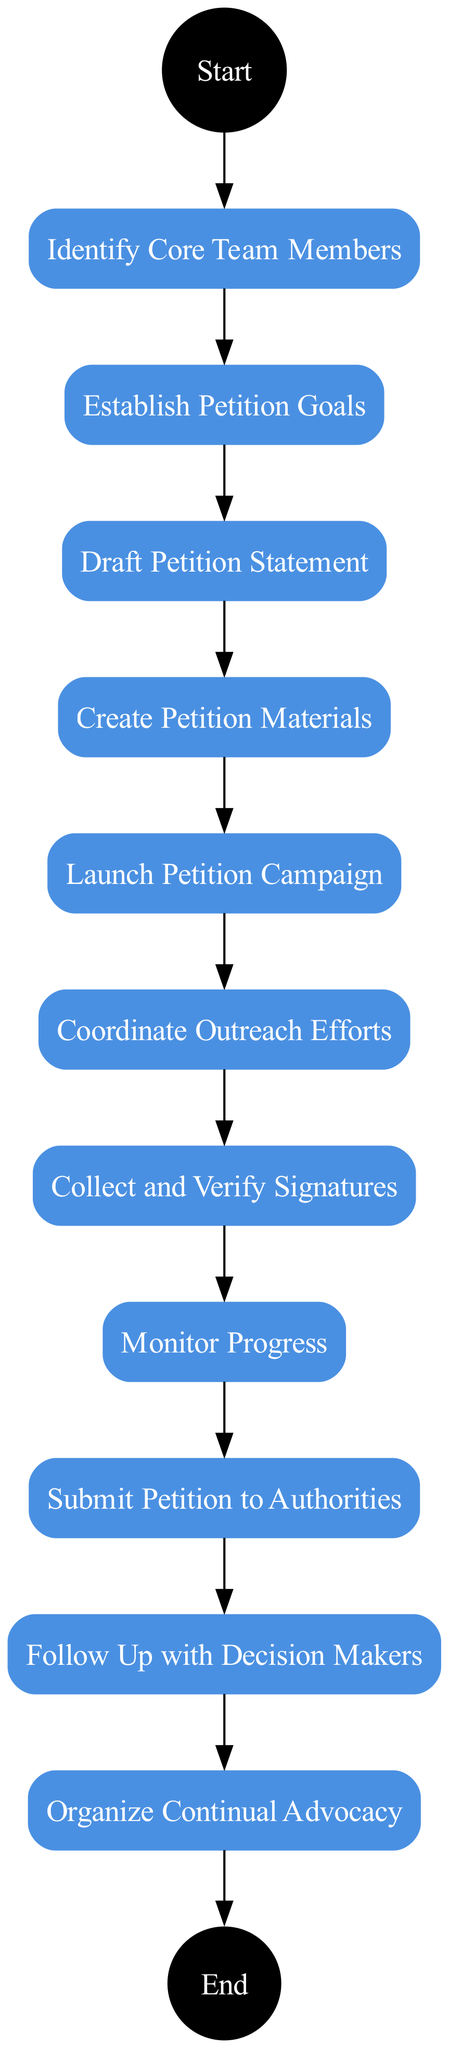What is the first activity in the diagram? The first activity is directly connected to the "Start" node, which is "Identify Core Team Members."
Answer: Identify Core Team Members How many activities are listed in the diagram? By counting each activity node present between "Start" and "End," there are ten activities total.
Answer: 10 What is the last activity before the "End" event? The last activity node is "Organize Continual Advocacy," which connects directly to the "End" node.
Answer: Organize Continual Advocacy What is the connection between "Draft Petition Statement" and "Create Petition Materials"? The connection is a direct edge in the diagram indicating a sequence; "Draft Petition Statement" leads to "Create Petition Materials."
Answer: Direct edge How many edges connect the activities from start to end? Each activity is connected in a linear fashion from "Start" through to "End," creating nine edges that connect ten activities.
Answer: 9 Which activity comes immediately after "Launch Petition Campaign"? The activity that follows "Launch Petition Campaign" is "Coordinate Outreach Efforts," as indicated by the directed flow in the diagram.
Answer: Coordinate Outreach Efforts What is the primary goal established in the activity "Establish Petition Goals"? The primary goal includes setting clear objectives, specifically the number of signatures needed for the petition.
Answer: Number of signatures needed Which two activities are centered around engaging with the community? The activities “Coordinate Outreach Efforts” and “Follow Up with Decision Makers” focus on community engagement in the petition process.
Answer: Coordinate Outreach Efforts, Follow Up with Decision Makers What action occurs after "Collect and Verify Signatures"? The action that follows is "Monitor Progress," indicating a systematic approach to tracking the collected signatures.
Answer: Monitor Progress 